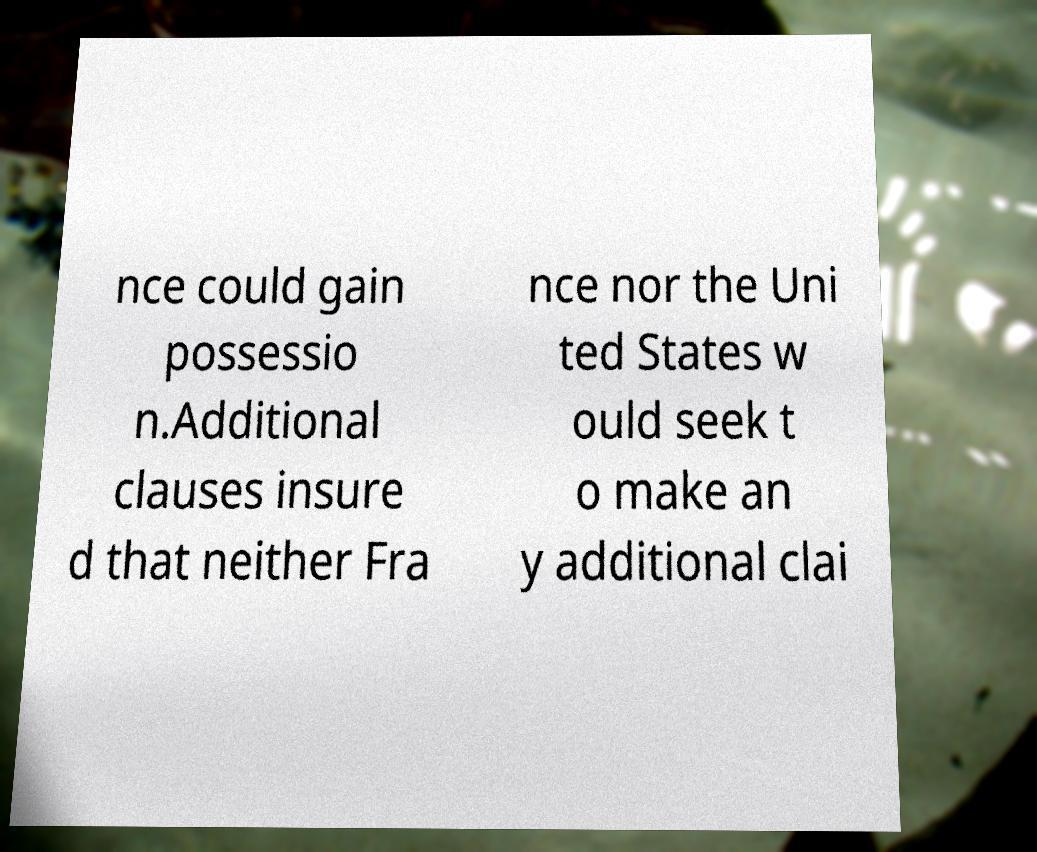Please read and relay the text visible in this image. What does it say? nce could gain possessio n.Additional clauses insure d that neither Fra nce nor the Uni ted States w ould seek t o make an y additional clai 